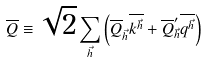<formula> <loc_0><loc_0><loc_500><loc_500>\overline { Q } \equiv \sqrt { 2 } \sum _ { \vec { h } } \left ( \overline { Q } _ { \vec { h } } \overline { k ^ { \vec { h } } } + \overline { Q } ^ { \prime } _ { \vec { h } } \overline { q ^ { \vec { h } } } \right )</formula> 